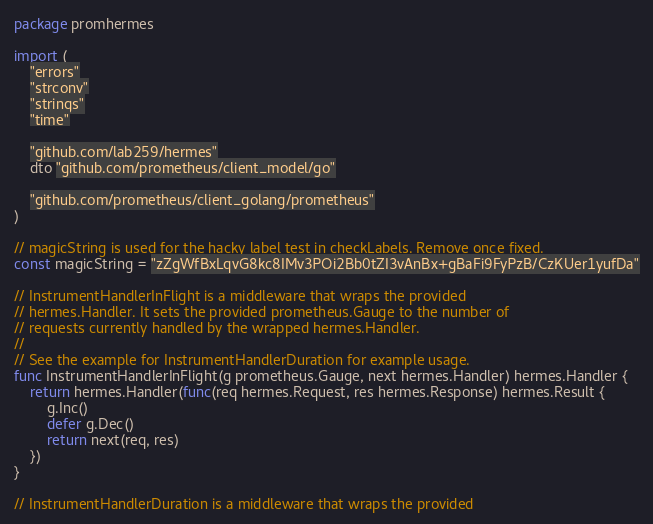Convert code to text. <code><loc_0><loc_0><loc_500><loc_500><_Go_>package promhermes

import (
	"errors"
	"strconv"
	"strings"
	"time"

	"github.com/lab259/hermes"
	dto "github.com/prometheus/client_model/go"

	"github.com/prometheus/client_golang/prometheus"
)

// magicString is used for the hacky label test in checkLabels. Remove once fixed.
const magicString = "zZgWfBxLqvG8kc8IMv3POi2Bb0tZI3vAnBx+gBaFi9FyPzB/CzKUer1yufDa"

// InstrumentHandlerInFlight is a middleware that wraps the provided
// hermes.Handler. It sets the provided prometheus.Gauge to the number of
// requests currently handled by the wrapped hermes.Handler.
//
// See the example for InstrumentHandlerDuration for example usage.
func InstrumentHandlerInFlight(g prometheus.Gauge, next hermes.Handler) hermes.Handler {
	return hermes.Handler(func(req hermes.Request, res hermes.Response) hermes.Result {
		g.Inc()
		defer g.Dec()
		return next(req, res)
	})
}

// InstrumentHandlerDuration is a middleware that wraps the provided</code> 